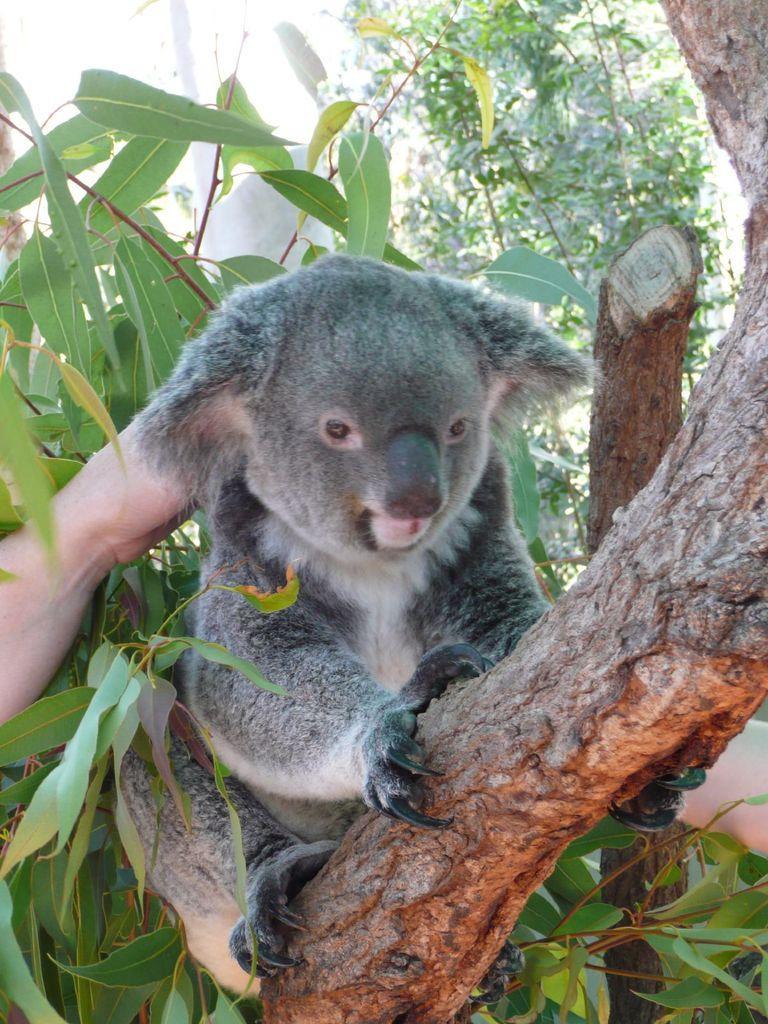Please provide a concise description of this image. In this image we can see an animal is sitting on a trees and on the left and right side we can see person's hand. In the background there are trees and log. 